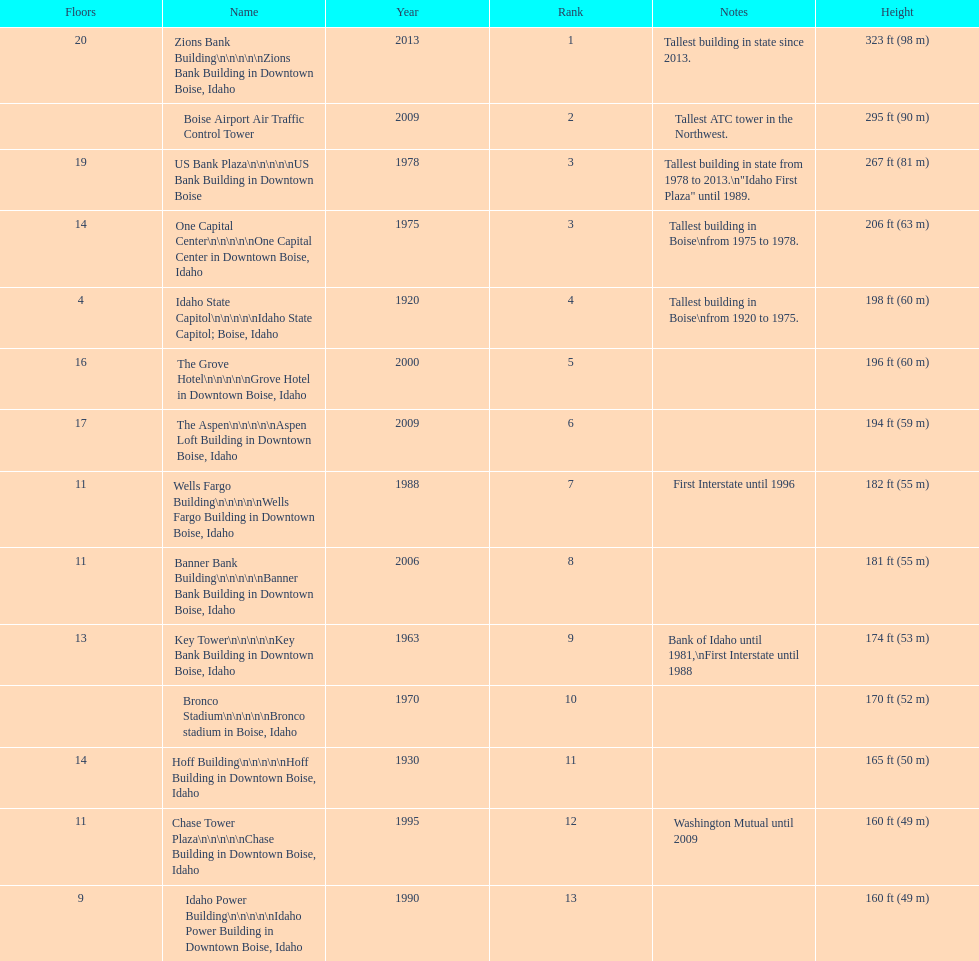According to the given diagram, which edifice has the maximum number of stories? Zions Bank Building. 